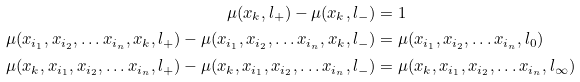<formula> <loc_0><loc_0><loc_500><loc_500>\mu ( x _ { k } , l _ { + } ) - \mu ( x _ { k } , l _ { - } ) & = 1 \\ \mu ( x _ { i _ { 1 } } , x _ { i _ { 2 } } , \dots x _ { i _ { n } } , x _ { k } , l _ { + } ) - \mu ( x _ { i _ { 1 } } , x _ { i _ { 2 } } , \dots x _ { i _ { n } } , x _ { k } , l _ { - } ) & = \mu ( x _ { i _ { 1 } } , x _ { i _ { 2 } } , \dots x _ { i _ { n } } , l _ { 0 } ) \\ \mu ( x _ { k } , x _ { i _ { 1 } } , x _ { i _ { 2 } } , \dots x _ { i _ { n } } , l _ { + } ) - \mu ( x _ { k } , x _ { i _ { 1 } } , x _ { i _ { 2 } } , \dots x _ { i _ { n } } , l _ { - } ) & = \mu ( x _ { k } , x _ { i _ { 1 } } , x _ { i _ { 2 } } , \dots x _ { i _ { n } } , l _ { \infty } )</formula> 